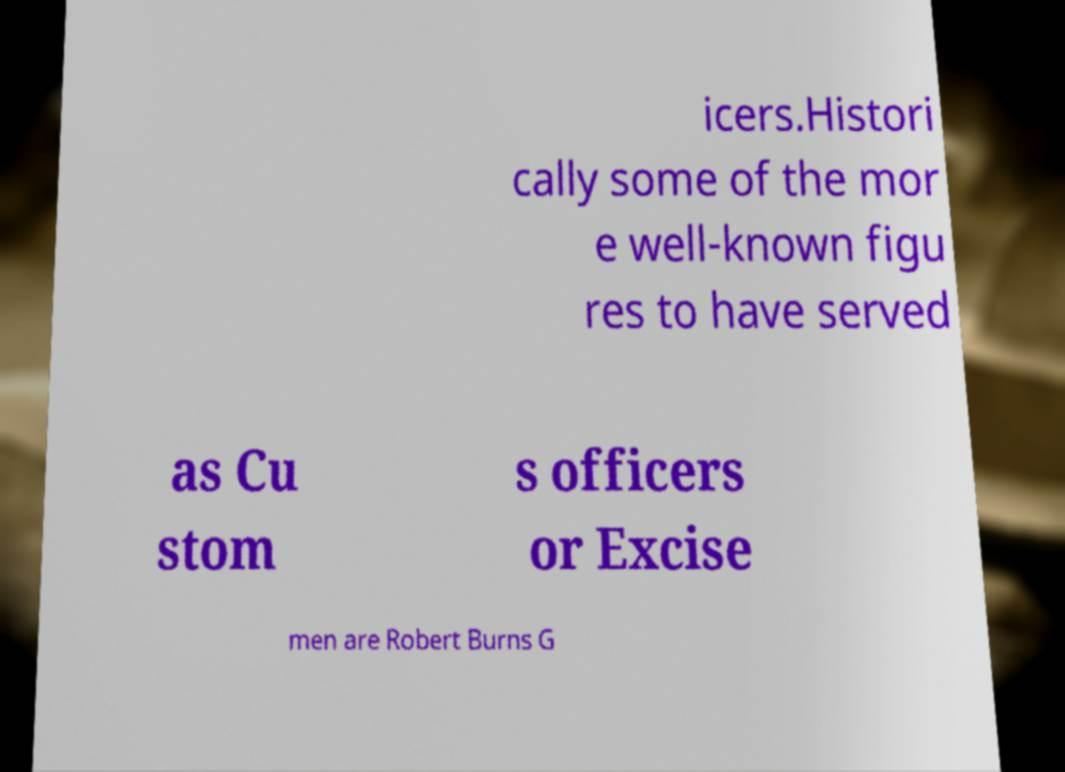Could you assist in decoding the text presented in this image and type it out clearly? icers.Histori cally some of the mor e well-known figu res to have served as Cu stom s officers or Excise men are Robert Burns G 